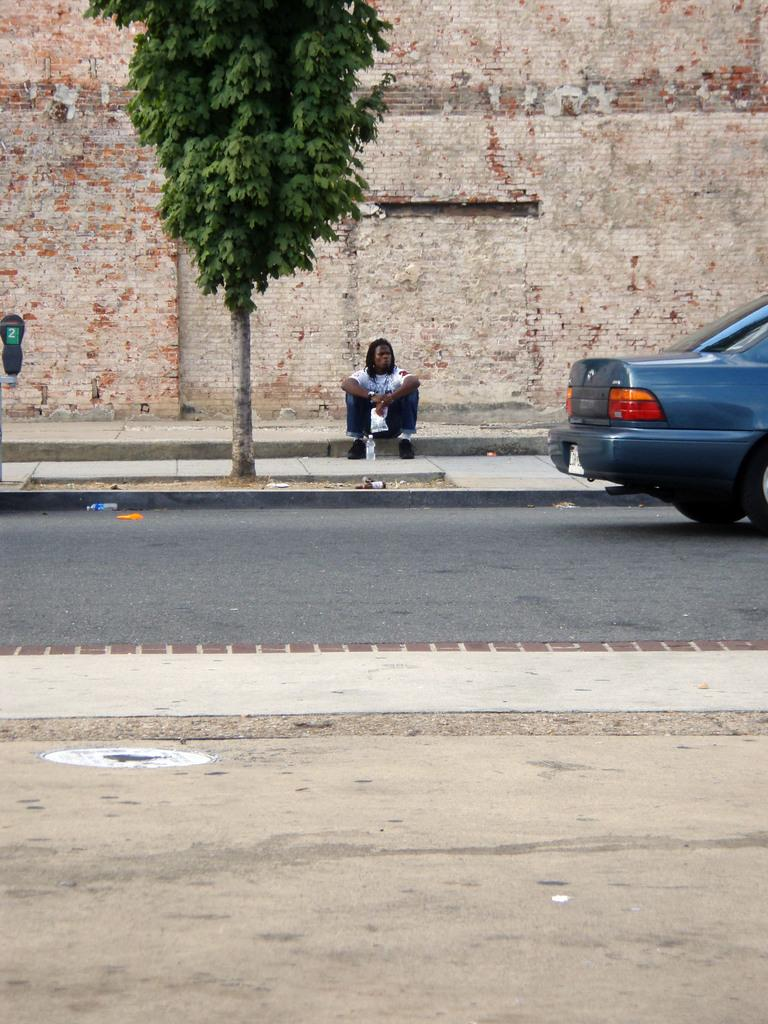What is the person in the image doing? There is a person sitting on the pavement in the image. What else can be seen in the image besides the person? There is a car, a board, a bottle on the road, and a wall visible in the image. How many clovers are growing on the wall in the image? There are no clovers visible on the wall in the image. What type of appliance is being used by the person sitting on the pavement? There is no appliance present in the image, and the person sitting on the pavement is not using any appliance. 